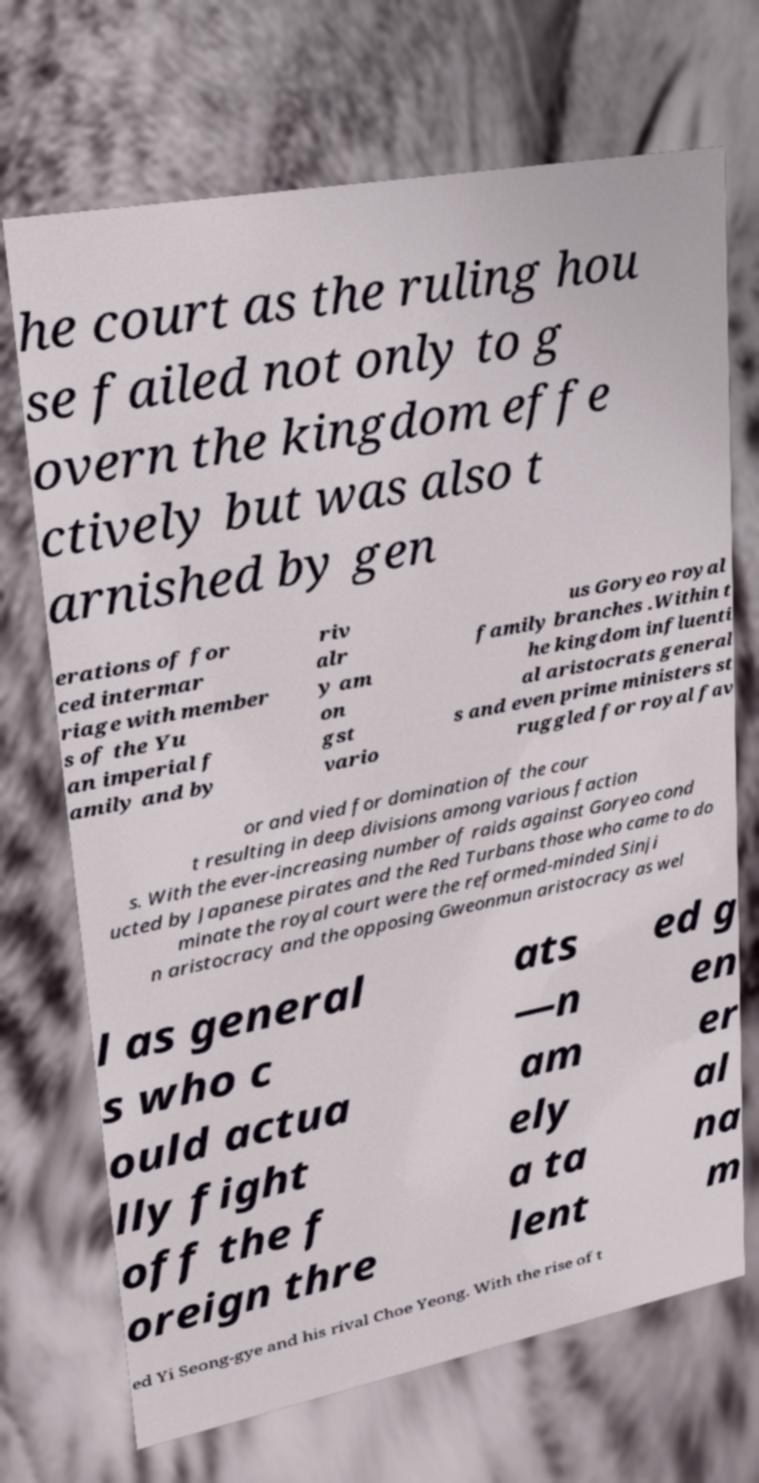Could you extract and type out the text from this image? he court as the ruling hou se failed not only to g overn the kingdom effe ctively but was also t arnished by gen erations of for ced intermar riage with member s of the Yu an imperial f amily and by riv alr y am on gst vario us Goryeo royal family branches .Within t he kingdom influenti al aristocrats general s and even prime ministers st ruggled for royal fav or and vied for domination of the cour t resulting in deep divisions among various faction s. With the ever-increasing number of raids against Goryeo cond ucted by Japanese pirates and the Red Turbans those who came to do minate the royal court were the reformed-minded Sinji n aristocracy and the opposing Gweonmun aristocracy as wel l as general s who c ould actua lly fight off the f oreign thre ats —n am ely a ta lent ed g en er al na m ed Yi Seong-gye and his rival Choe Yeong. With the rise of t 